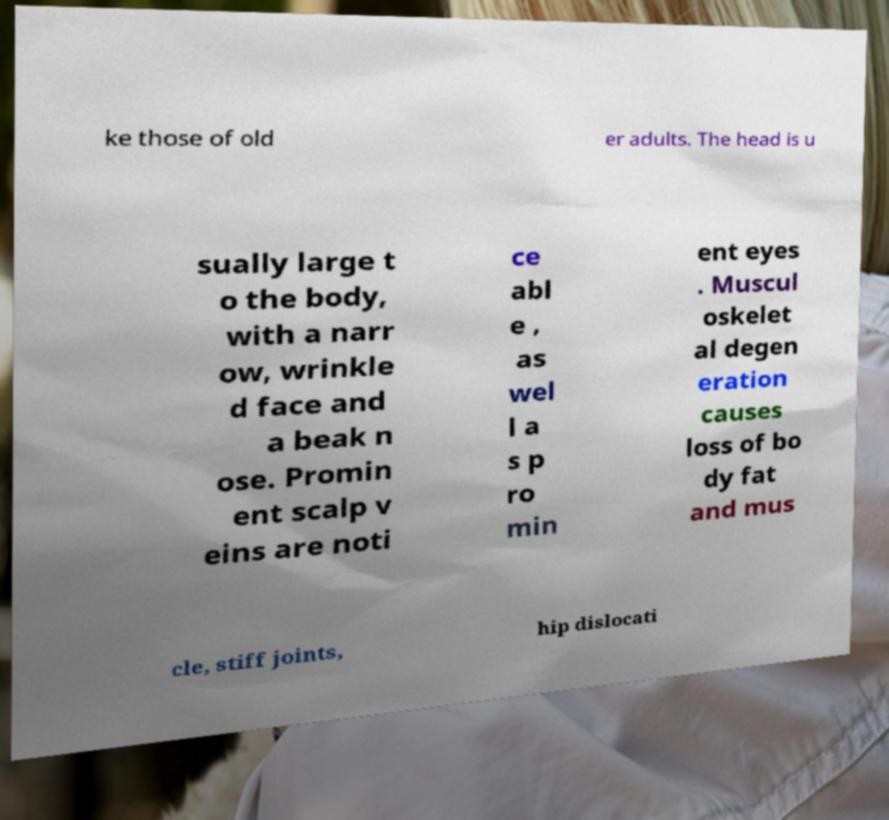What messages or text are displayed in this image? I need them in a readable, typed format. ke those of old er adults. The head is u sually large t o the body, with a narr ow, wrinkle d face and a beak n ose. Promin ent scalp v eins are noti ce abl e , as wel l a s p ro min ent eyes . Muscul oskelet al degen eration causes loss of bo dy fat and mus cle, stiff joints, hip dislocati 